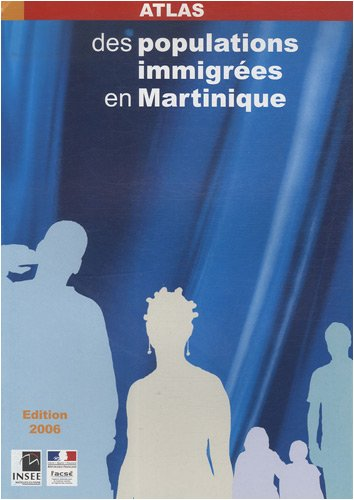What insights can one gain about Martinique from this book? This atlas provides insights into the social and demographic fabric of Martinique, highlighting the diversity and distribution of immigrant populations. It's useful for understanding migration patterns, cultural diversity, and regional demographic developments. 